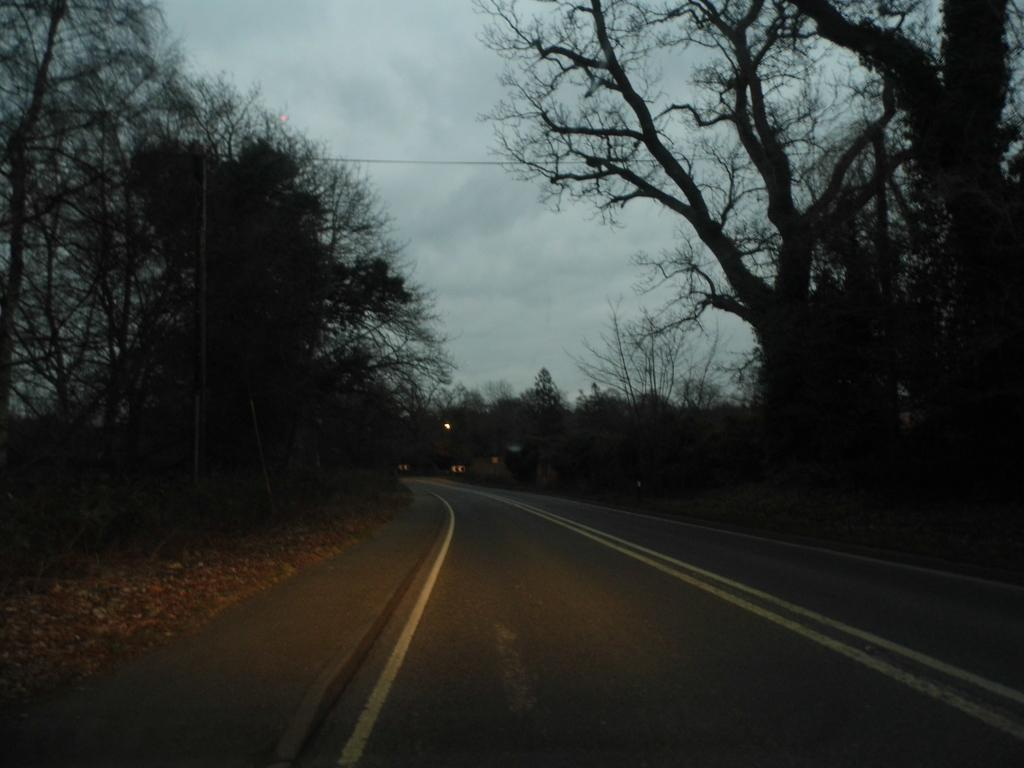What can be seen in the background of the image? The sky is visible in the background of the image. What type of vegetation is present on the sides of the image? There are trees on both the right and left sides of the image. What is the main feature of the image? There is a road in the image. What type of grip does the skin of the trees have in the image? There is no mention of the trees having skin or a grip in the image, as these are not applicable to trees. 